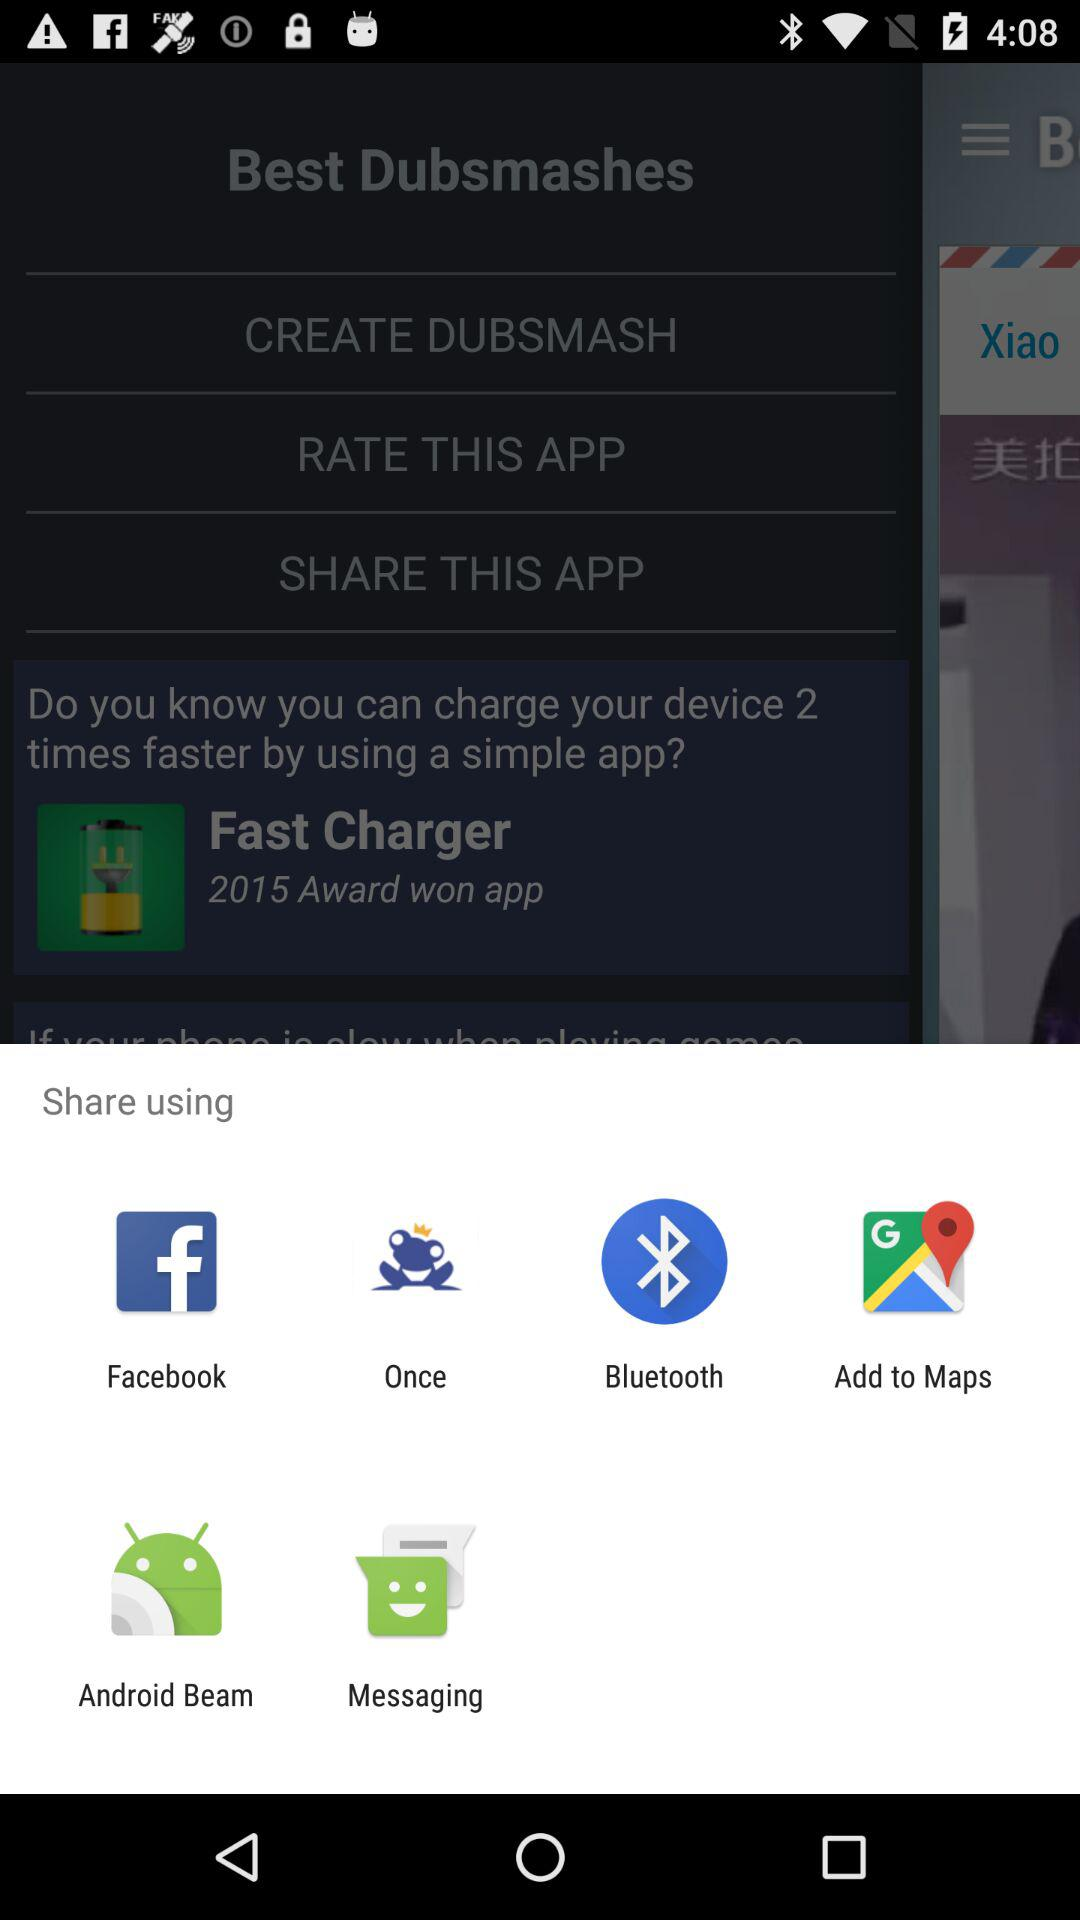How many ratings does this application have?
When the provided information is insufficient, respond with <no answer>. <no answer> 